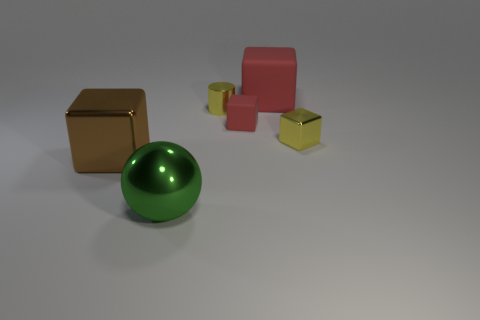Do the green metal object and the big thing on the left side of the big metal sphere have the same shape?
Offer a terse response. No. What is the material of the large thing that is behind the small metallic block on the right side of the red object that is in front of the big matte object?
Make the answer very short. Rubber. How many brown things are there?
Your response must be concise. 1. What number of red things are tiny blocks or tiny objects?
Your response must be concise. 1. How many other things are there of the same shape as the big red rubber thing?
Offer a very short reply. 3. Do the small block in front of the small rubber thing and the object that is on the left side of the large sphere have the same color?
Make the answer very short. No. How many large things are either metallic balls or brown metal cubes?
Your response must be concise. 2. What size is the other yellow thing that is the same shape as the large matte object?
Keep it short and to the point. Small. Is there any other thing that has the same size as the cylinder?
Give a very brief answer. Yes. The large object to the right of the matte thing that is in front of the yellow shiny cylinder is made of what material?
Your answer should be compact. Rubber. 